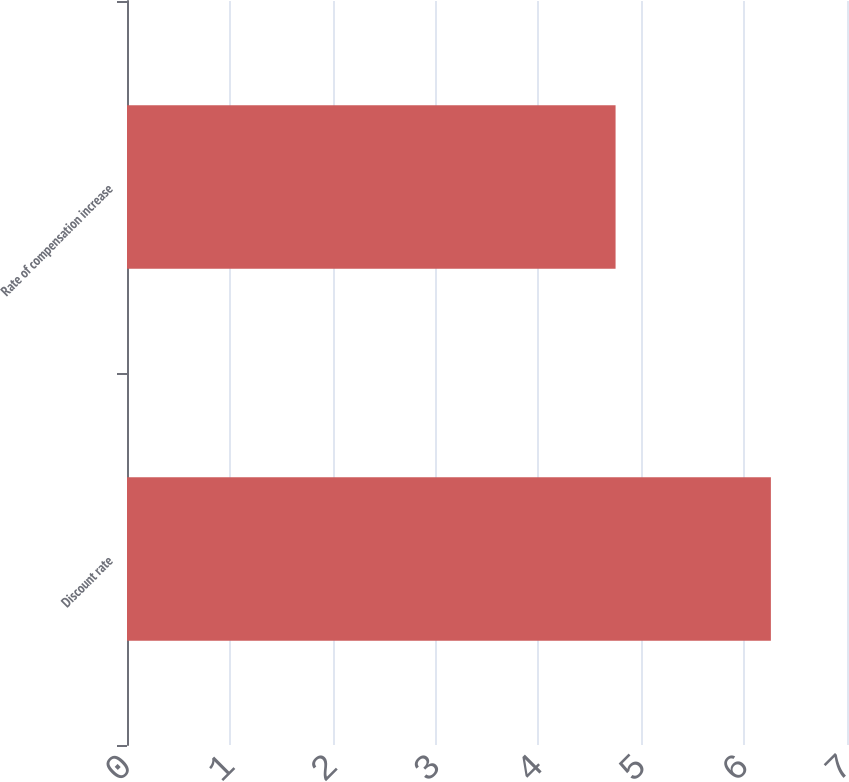<chart> <loc_0><loc_0><loc_500><loc_500><bar_chart><fcel>Discount rate<fcel>Rate of compensation increase<nl><fcel>6.26<fcel>4.75<nl></chart> 